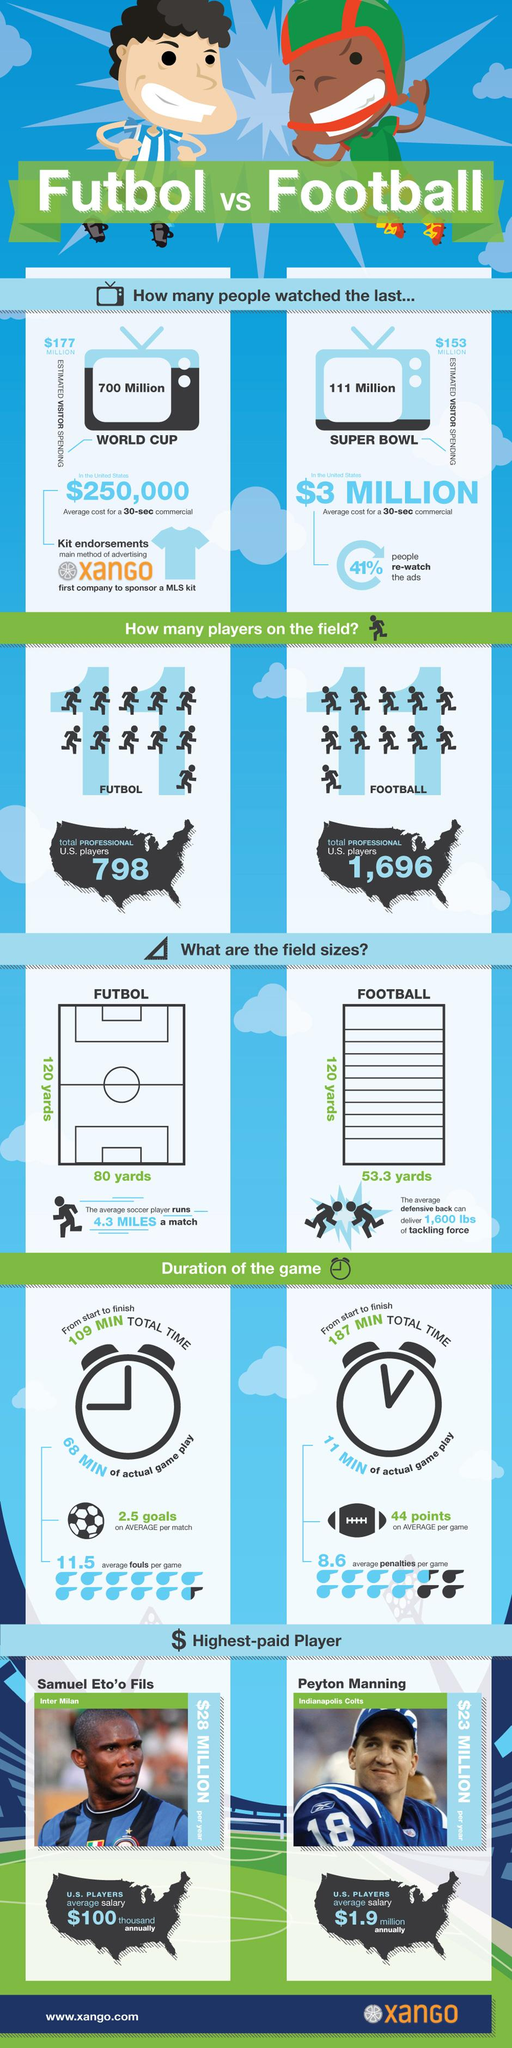Identify some key points in this picture. The football field has a breadth of 53.3 yards. This breadth is comprised of 120 yards on the main playing field and 80 yards on the side lines. However, it is important to note that the length of the field can vary depending on the league and country in which the game is played. The number of players on the field for both futbol and football is 11. The duration of a futbol game is 109 minutes, 187 minutes, or 68 minutes. Samuel Eto'o Fils is the highest paid football player, and not Peyton Manning. Peyton Manning's jersey number is 18. 